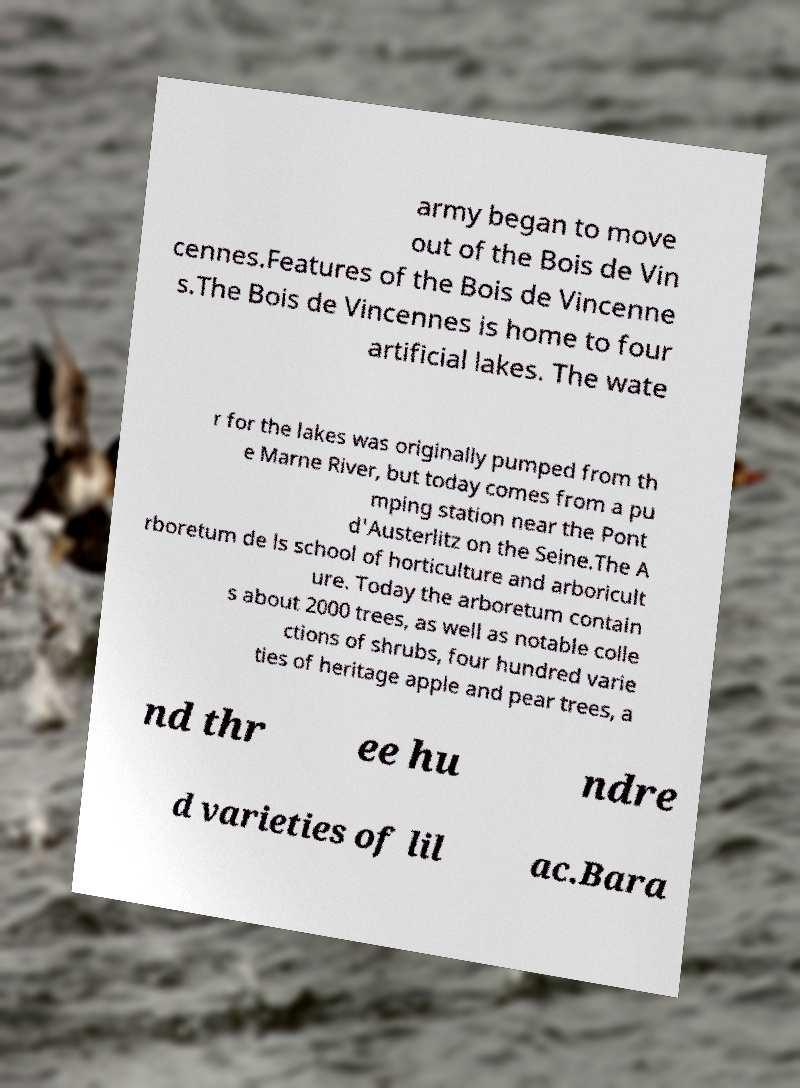Could you assist in decoding the text presented in this image and type it out clearly? army began to move out of the Bois de Vin cennes.Features of the Bois de Vincenne s.The Bois de Vincennes is home to four artificial lakes. The wate r for the lakes was originally pumped from th e Marne River, but today comes from a pu mping station near the Pont d'Austerlitz on the Seine.The A rboretum de ls school of horticulture and arboricult ure. Today the arboretum contain s about 2000 trees, as well as notable colle ctions of shrubs, four hundred varie ties of heritage apple and pear trees, a nd thr ee hu ndre d varieties of lil ac.Bara 